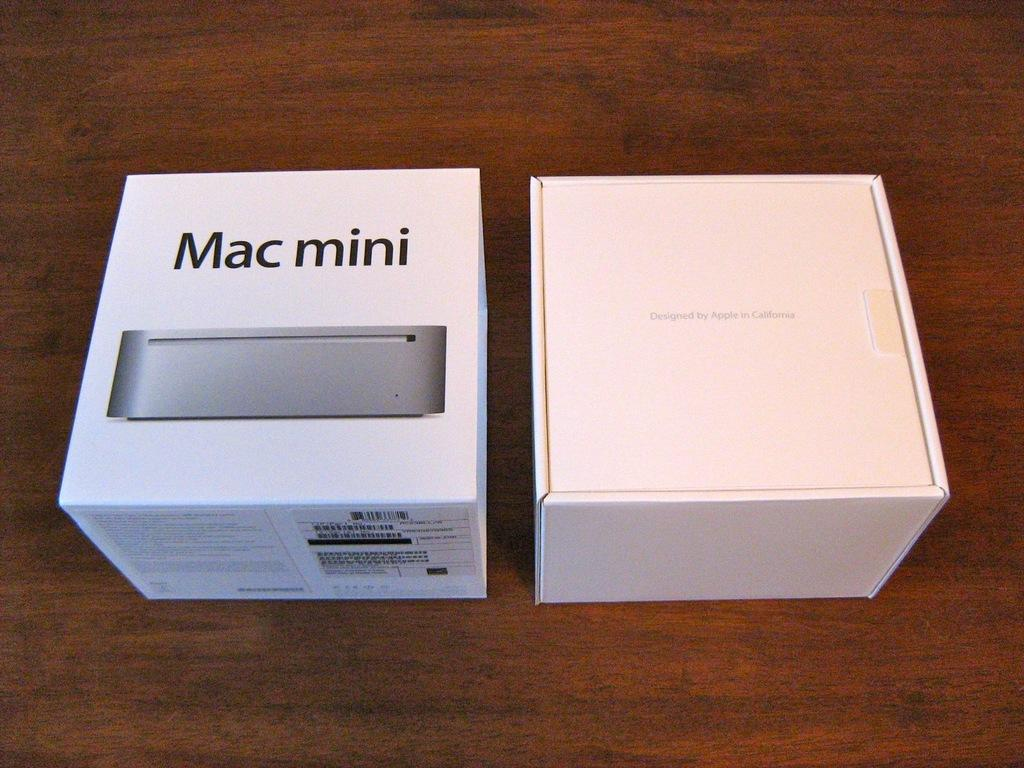<image>
Present a compact description of the photo's key features. The card box shown contains a Mac mini. 